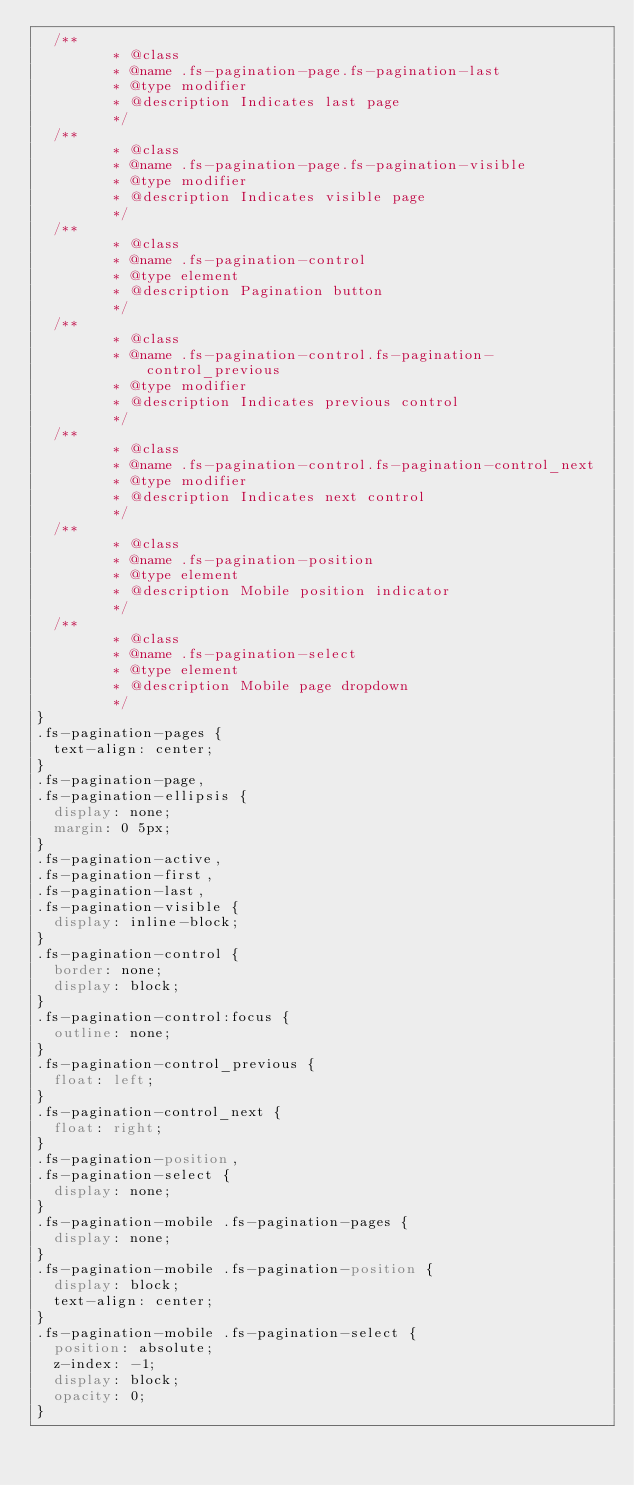Convert code to text. <code><loc_0><loc_0><loc_500><loc_500><_CSS_>  /**
		 * @class
		 * @name .fs-pagination-page.fs-pagination-last
		 * @type modifier
		 * @description Indicates last page
		 */
  /**
		 * @class
		 * @name .fs-pagination-page.fs-pagination-visible
		 * @type modifier
		 * @description Indicates visible page
		 */
  /**
		 * @class
		 * @name .fs-pagination-control
		 * @type element
		 * @description Pagination button
		 */
  /**
		 * @class
		 * @name .fs-pagination-control.fs-pagination-control_previous
		 * @type modifier
		 * @description Indicates previous control
		 */
  /**
		 * @class
		 * @name .fs-pagination-control.fs-pagination-control_next
		 * @type modifier
		 * @description Indicates next control
		 */
  /**
		 * @class
		 * @name .fs-pagination-position
		 * @type element
		 * @description Mobile position indicator
		 */
  /**
		 * @class
		 * @name .fs-pagination-select
		 * @type element
		 * @description Mobile page dropdown
		 */
}
.fs-pagination-pages {
  text-align: center;
}
.fs-pagination-page,
.fs-pagination-ellipsis {
  display: none;
  margin: 0 5px;
}
.fs-pagination-active,
.fs-pagination-first,
.fs-pagination-last,
.fs-pagination-visible {
  display: inline-block;
}
.fs-pagination-control {
  border: none;
  display: block;
}
.fs-pagination-control:focus {
  outline: none;
}
.fs-pagination-control_previous {
  float: left;
}
.fs-pagination-control_next {
  float: right;
}
.fs-pagination-position,
.fs-pagination-select {
  display: none;
}
.fs-pagination-mobile .fs-pagination-pages {
  display: none;
}
.fs-pagination-mobile .fs-pagination-position {
  display: block;
  text-align: center;
}
.fs-pagination-mobile .fs-pagination-select {
  position: absolute;
  z-index: -1;
  display: block;
  opacity: 0;
}
</code> 